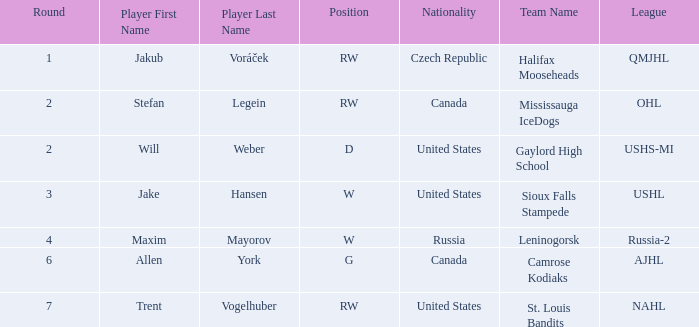Would you be able to parse every entry in this table? {'header': ['Round', 'Player First Name', 'Player Last Name', 'Position', 'Nationality', 'Team Name', 'League'], 'rows': [['1', 'Jakub', 'Voráček', 'RW', 'Czech Republic', 'Halifax Mooseheads', 'QMJHL'], ['2', 'Stefan', 'Legein', 'RW', 'Canada', 'Mississauga IceDogs', 'OHL'], ['2', 'Will', 'Weber', 'D', 'United States', 'Gaylord High School', 'USHS-MI'], ['3', 'Jake', 'Hansen', 'W', 'United States', 'Sioux Falls Stampede', 'USHL'], ['4', 'Maxim', 'Mayorov', 'W', 'Russia', 'Leninogorsk', 'Russia-2'], ['6', 'Allen', 'York', 'G', 'Canada', 'Camrose Kodiaks', 'AJHL'], ['7', 'Trent', 'Vogelhuber', 'RW', 'United States', 'St. Louis Bandits', 'NAHL']]} What college or league did the round 2 pick with d position come from? Gaylord High School ( USHS-MI ). 